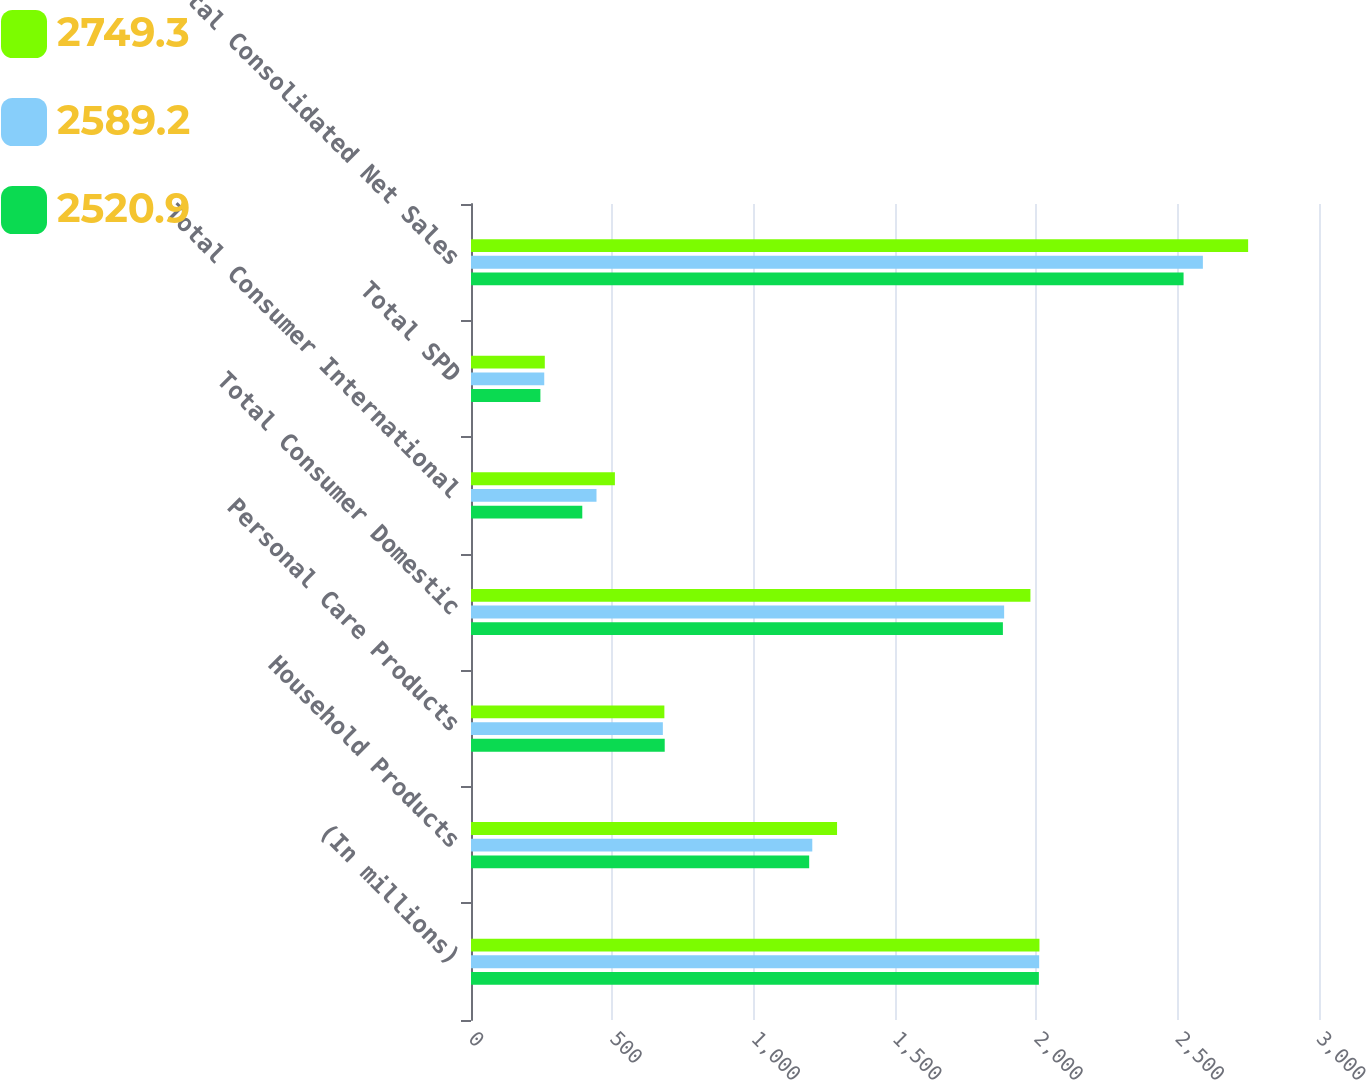Convert chart to OTSL. <chart><loc_0><loc_0><loc_500><loc_500><stacked_bar_chart><ecel><fcel>(In millions)<fcel>Household Products<fcel>Personal Care Products<fcel>Total Consumer Domestic<fcel>Total Consumer International<fcel>Total SPD<fcel>Total Consolidated Net Sales<nl><fcel>2749.3<fcel>2011<fcel>1295<fcel>684.1<fcel>1979.1<fcel>509.1<fcel>261.1<fcel>2749.3<nl><fcel>2589.2<fcel>2010<fcel>1207.4<fcel>678.7<fcel>1886.1<fcel>444<fcel>259.1<fcel>2589.2<nl><fcel>2520.9<fcel>2009<fcel>1196.4<fcel>685.3<fcel>1881.7<fcel>393.7<fcel>245.5<fcel>2520.9<nl></chart> 